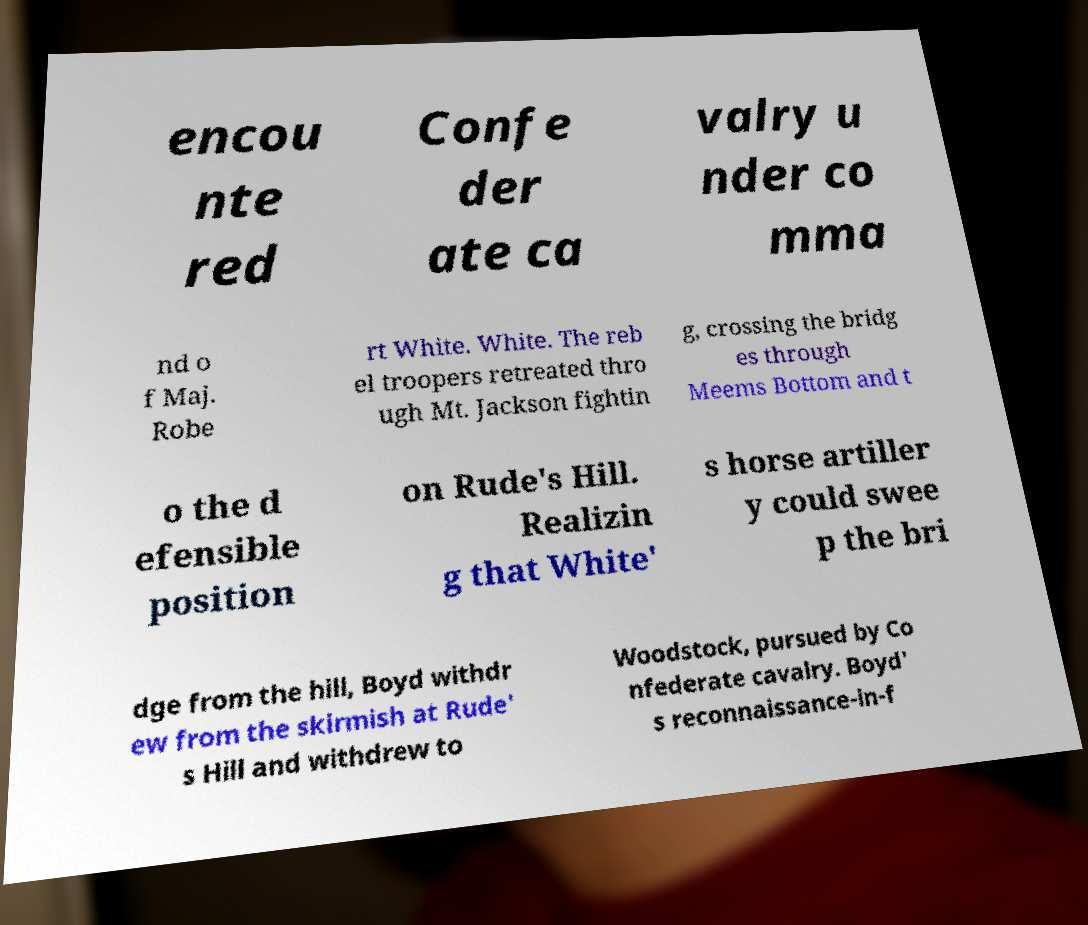Can you read and provide the text displayed in the image?This photo seems to have some interesting text. Can you extract and type it out for me? encou nte red Confe der ate ca valry u nder co mma nd o f Maj. Robe rt White. White. The reb el troopers retreated thro ugh Mt. Jackson fightin g, crossing the bridg es through Meems Bottom and t o the d efensible position on Rude's Hill. Realizin g that White' s horse artiller y could swee p the bri dge from the hill, Boyd withdr ew from the skirmish at Rude' s Hill and withdrew to Woodstock, pursued by Co nfederate cavalry. Boyd' s reconnaissance-in-f 